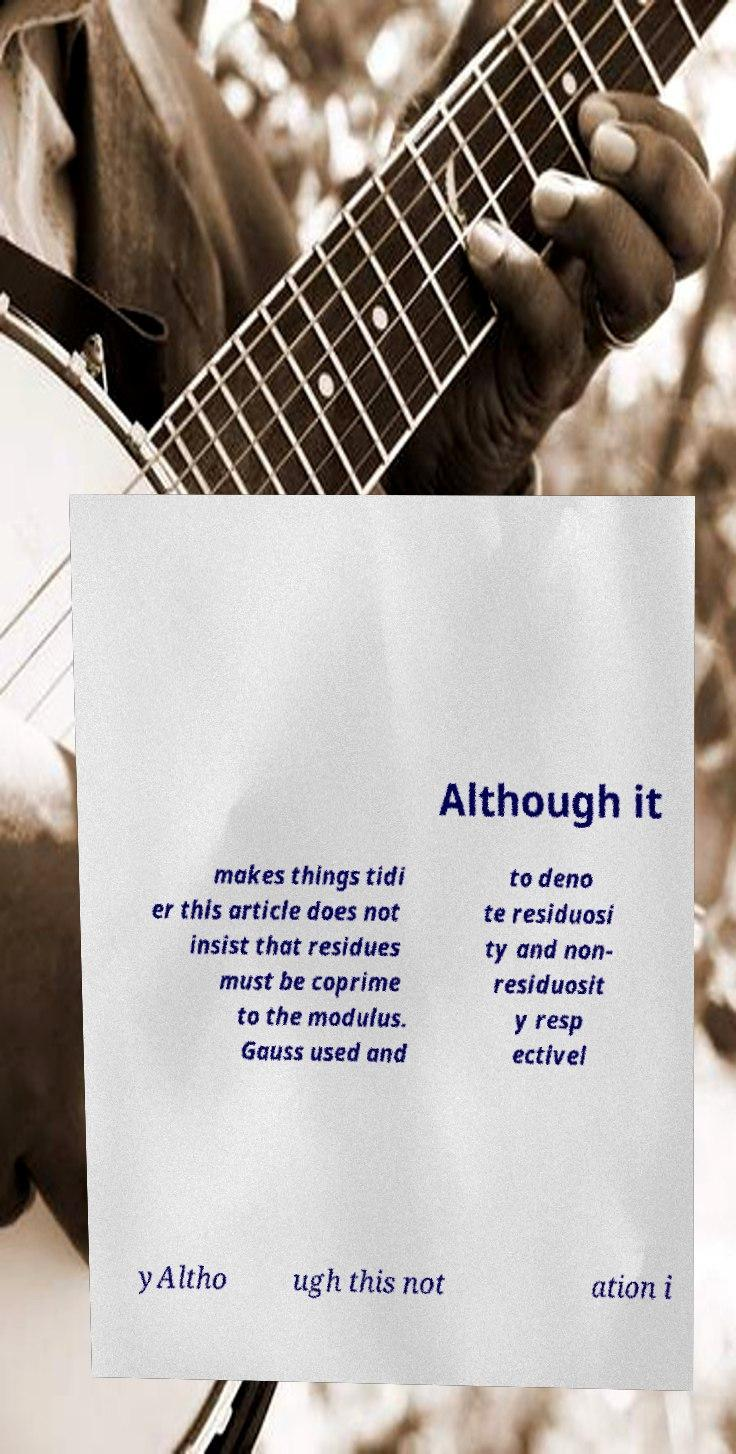For documentation purposes, I need the text within this image transcribed. Could you provide that? Although it makes things tidi er this article does not insist that residues must be coprime to the modulus. Gauss used and to deno te residuosi ty and non- residuosit y resp ectivel yAltho ugh this not ation i 